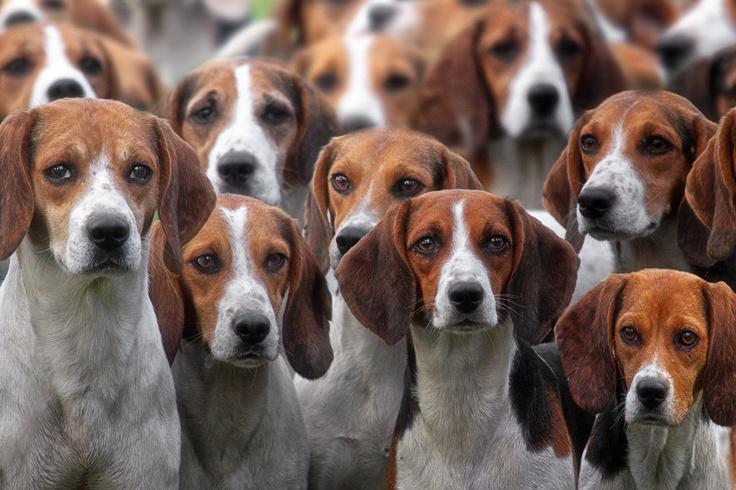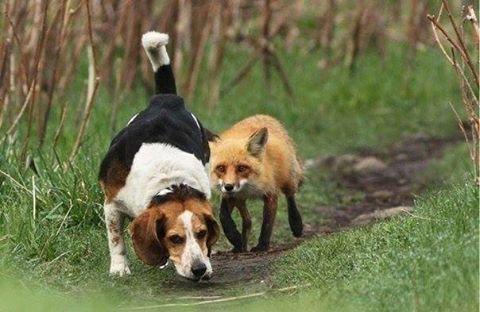The first image is the image on the left, the second image is the image on the right. Evaluate the accuracy of this statement regarding the images: "An image contains exactly one dog, a beagle puppy that is sitting on green grass.". Is it true? Answer yes or no. No. The first image is the image on the left, the second image is the image on the right. For the images shown, is this caption "The right image contains no more than three dogs." true? Answer yes or no. Yes. 